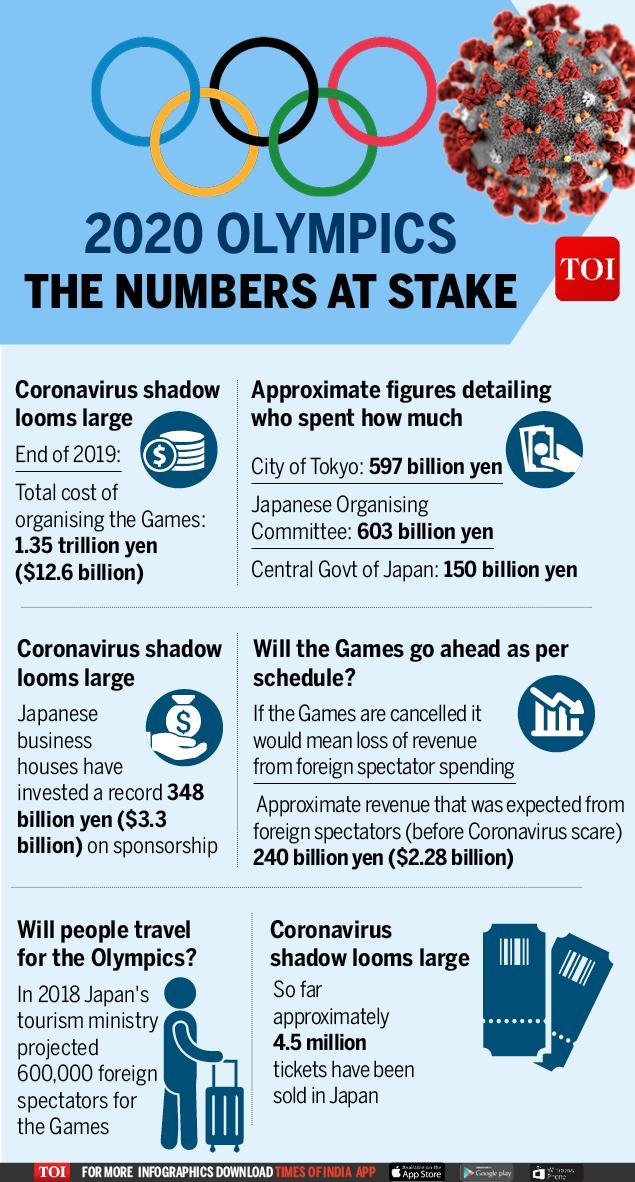Which news channel has published the findings of 2020 Olympics - the Numbers at Stake
Answer the question with a short phrase. TOI What is the total cost of organising the games in yen 348 billion yen How much investment in billion by Japanese business houses $3.3 What is the total cost of organising the games in billion $12.6 billion How much revenue in billions is expected from foreign spectators $2.28 How many rings in the Olympic logo 5 